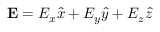Convert formula to latex. <formula><loc_0><loc_0><loc_500><loc_500>E = E _ { x } \hat { x } + E _ { y } \hat { y } + E _ { z } \hat { z }</formula> 